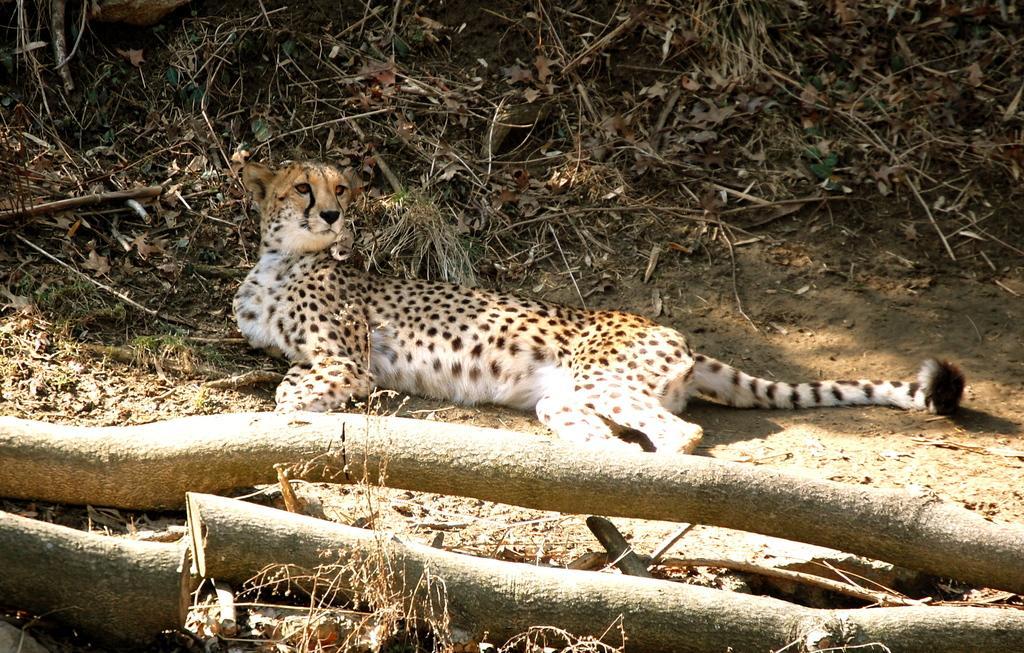Can you describe this image briefly? In the image there is a cheetah laying on the ground and around the cheetah there are dry leaves, dry grass and few wooden logs. A huge sunlight is falling on the wooden logs. 